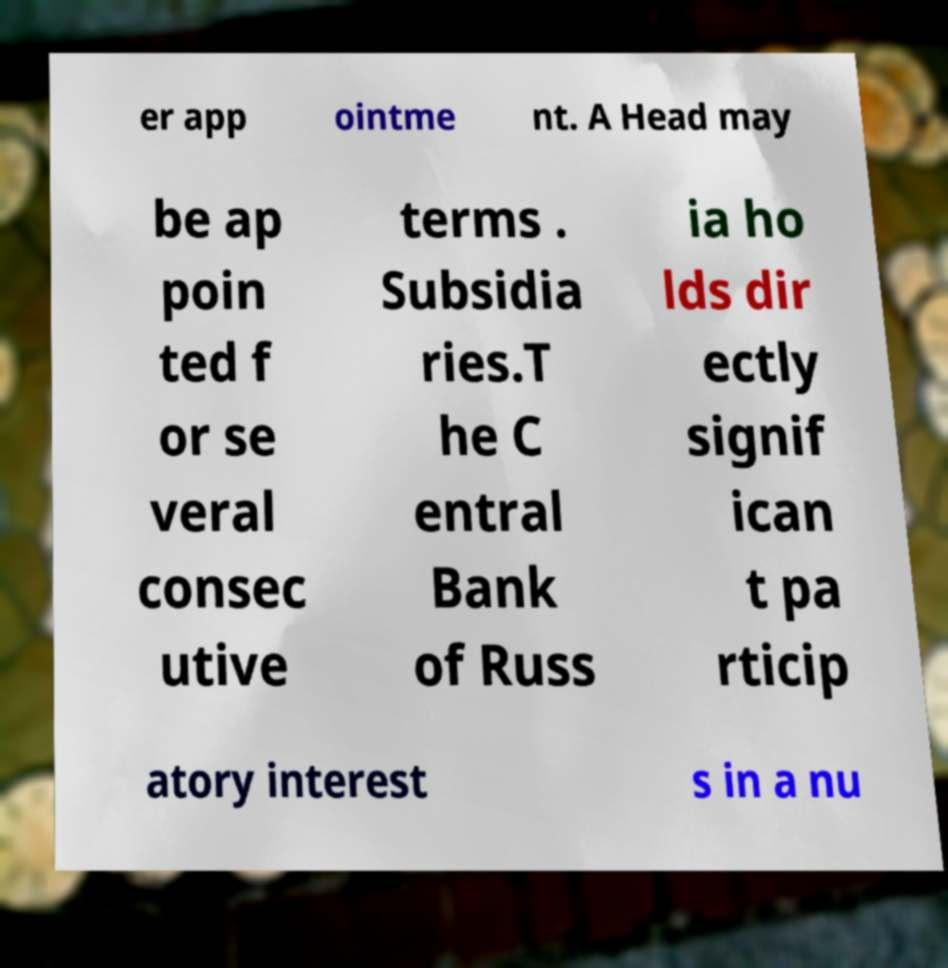Can you accurately transcribe the text from the provided image for me? er app ointme nt. A Head may be ap poin ted f or se veral consec utive terms . Subsidia ries.T he C entral Bank of Russ ia ho lds dir ectly signif ican t pa rticip atory interest s in a nu 